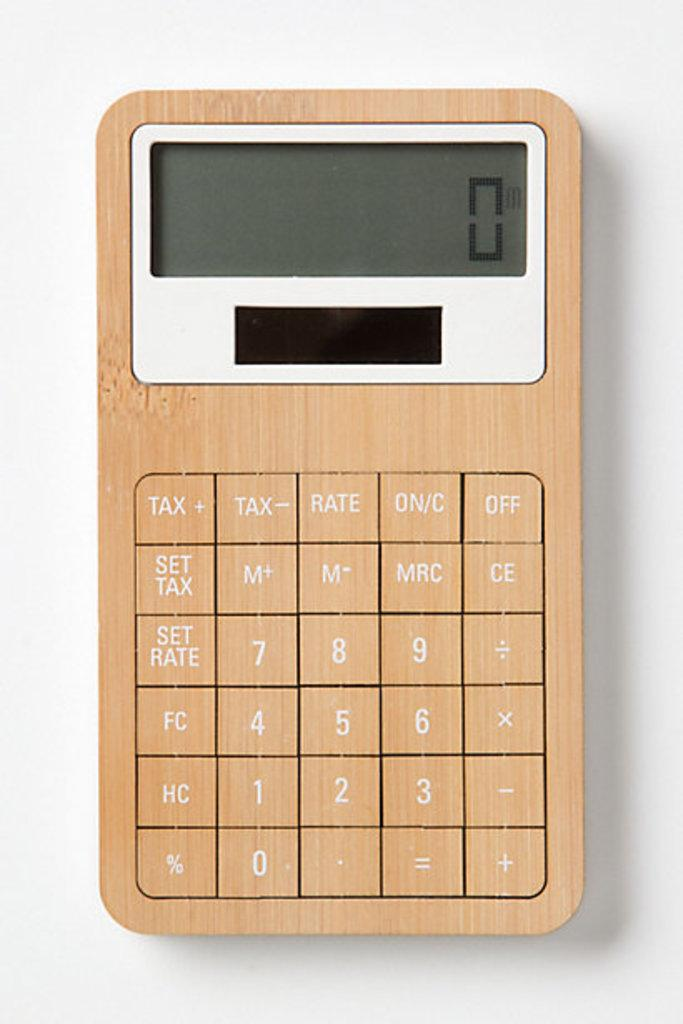<image>
Render a clear and concise summary of the photo. A basic calculator with a bamboo finish with the number "0" on the screen. 